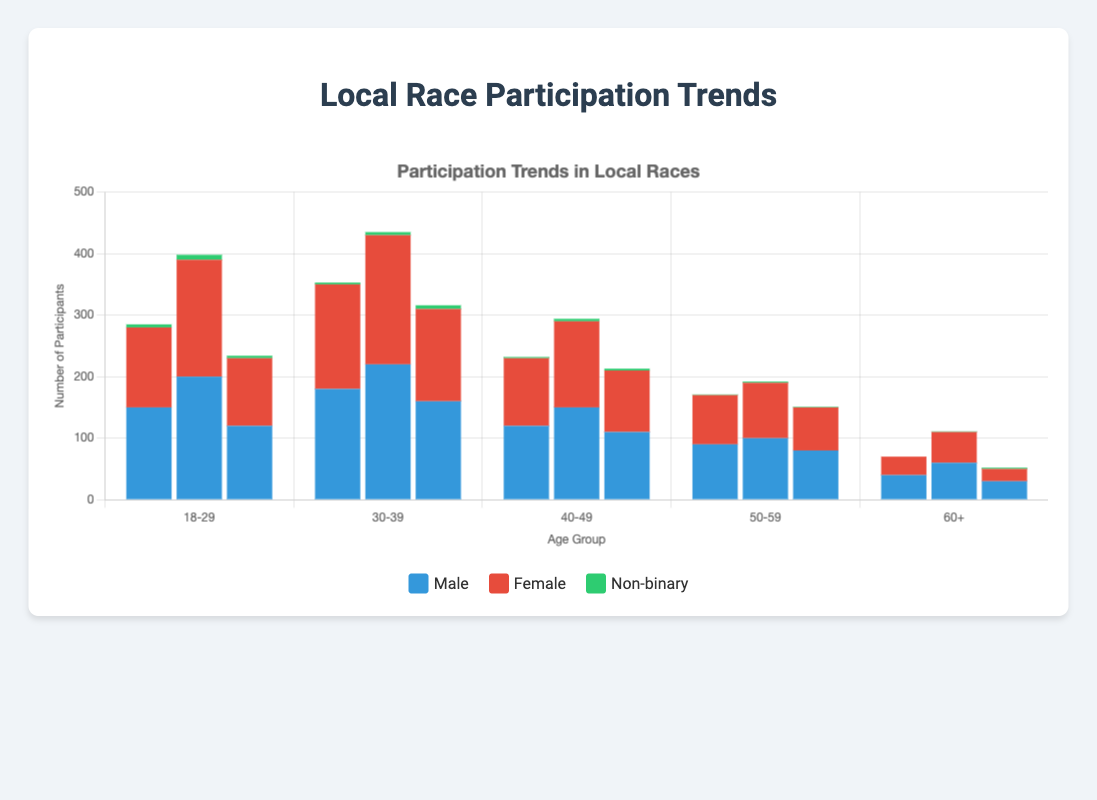How many male participants were in the 18-29 age group across all events? Sum the male participants in the 18-29 age group for each event: 150 (City Marathon) + 200 (Town Fun Run) + 120 (Community Charity Run) = 470
Answer: 470 Which event had the highest total participation in the 30-39 age group? Compare the total number of participants (male + female + non-binary) in the 30-39 age group across all events: 353 (City Marathon) vs. 435 (Town Fun Run) vs. 316 (Community Charity Run). The highest is 435 in Town Fun Run.
Answer: Town Fun Run Which gender had the most participants in the 60+ age group in the City Marathon? Look at the participation numbers for each gender in the 60+ group: 40 (male), 30 (female), 0 (non-binary). Therefore, the male participants were the most.
Answer: Male What is the average number of female participants in the 40-49 age group across all events? Sum the female participants in the 40-49 age group: 110 (City Marathon) + 140 (Town Fun Run) + 100 (Community Charity Run) = 350. Then divide by the number of events: 350 / 3 = 116.67
Answer: 116.67 How many non-binary participants were there in total for the Town Fun Run? Sum the non-binary participants in all age groups for Town Fun Run: 8 (18-29) + 5 (30-39) + 4 (40-49) + 2 (50-59) + 1 (60+) = 20
Answer: 20 Which age group had the lowest number of total participants in the Community Charity Run? Sum the total participants (male + female + non-binary) for each age group: 18-29 (234), 30-39 (316), 40-49 (213), 50-59 (151), 60+ (52). The lowest is 52 in the 60+ age group.
Answer: 60+ Was the number of female participants in the 30-39 age group greater in Town Fun Run or City Marathon? Compare the female participants in the 30-39 age group: Town Fun Run (210) vs. City Marathon (170). Town Fun Run was greater.
Answer: Town Fun Run In which event were there more non-binary participants in the 18-29 age group: the City Marathon or the Community Charity Run? Compare the non-binary participants in the 18-29 age group: City Marathon (5) vs. Community Charity Run (4). City Marathon had more.
Answer: City Marathon 